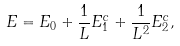<formula> <loc_0><loc_0><loc_500><loc_500>E = E _ { 0 } + \frac { 1 } { L } E _ { 1 } ^ { c } + \frac { 1 } { L ^ { 2 } } E _ { 2 } ^ { c } ,</formula> 